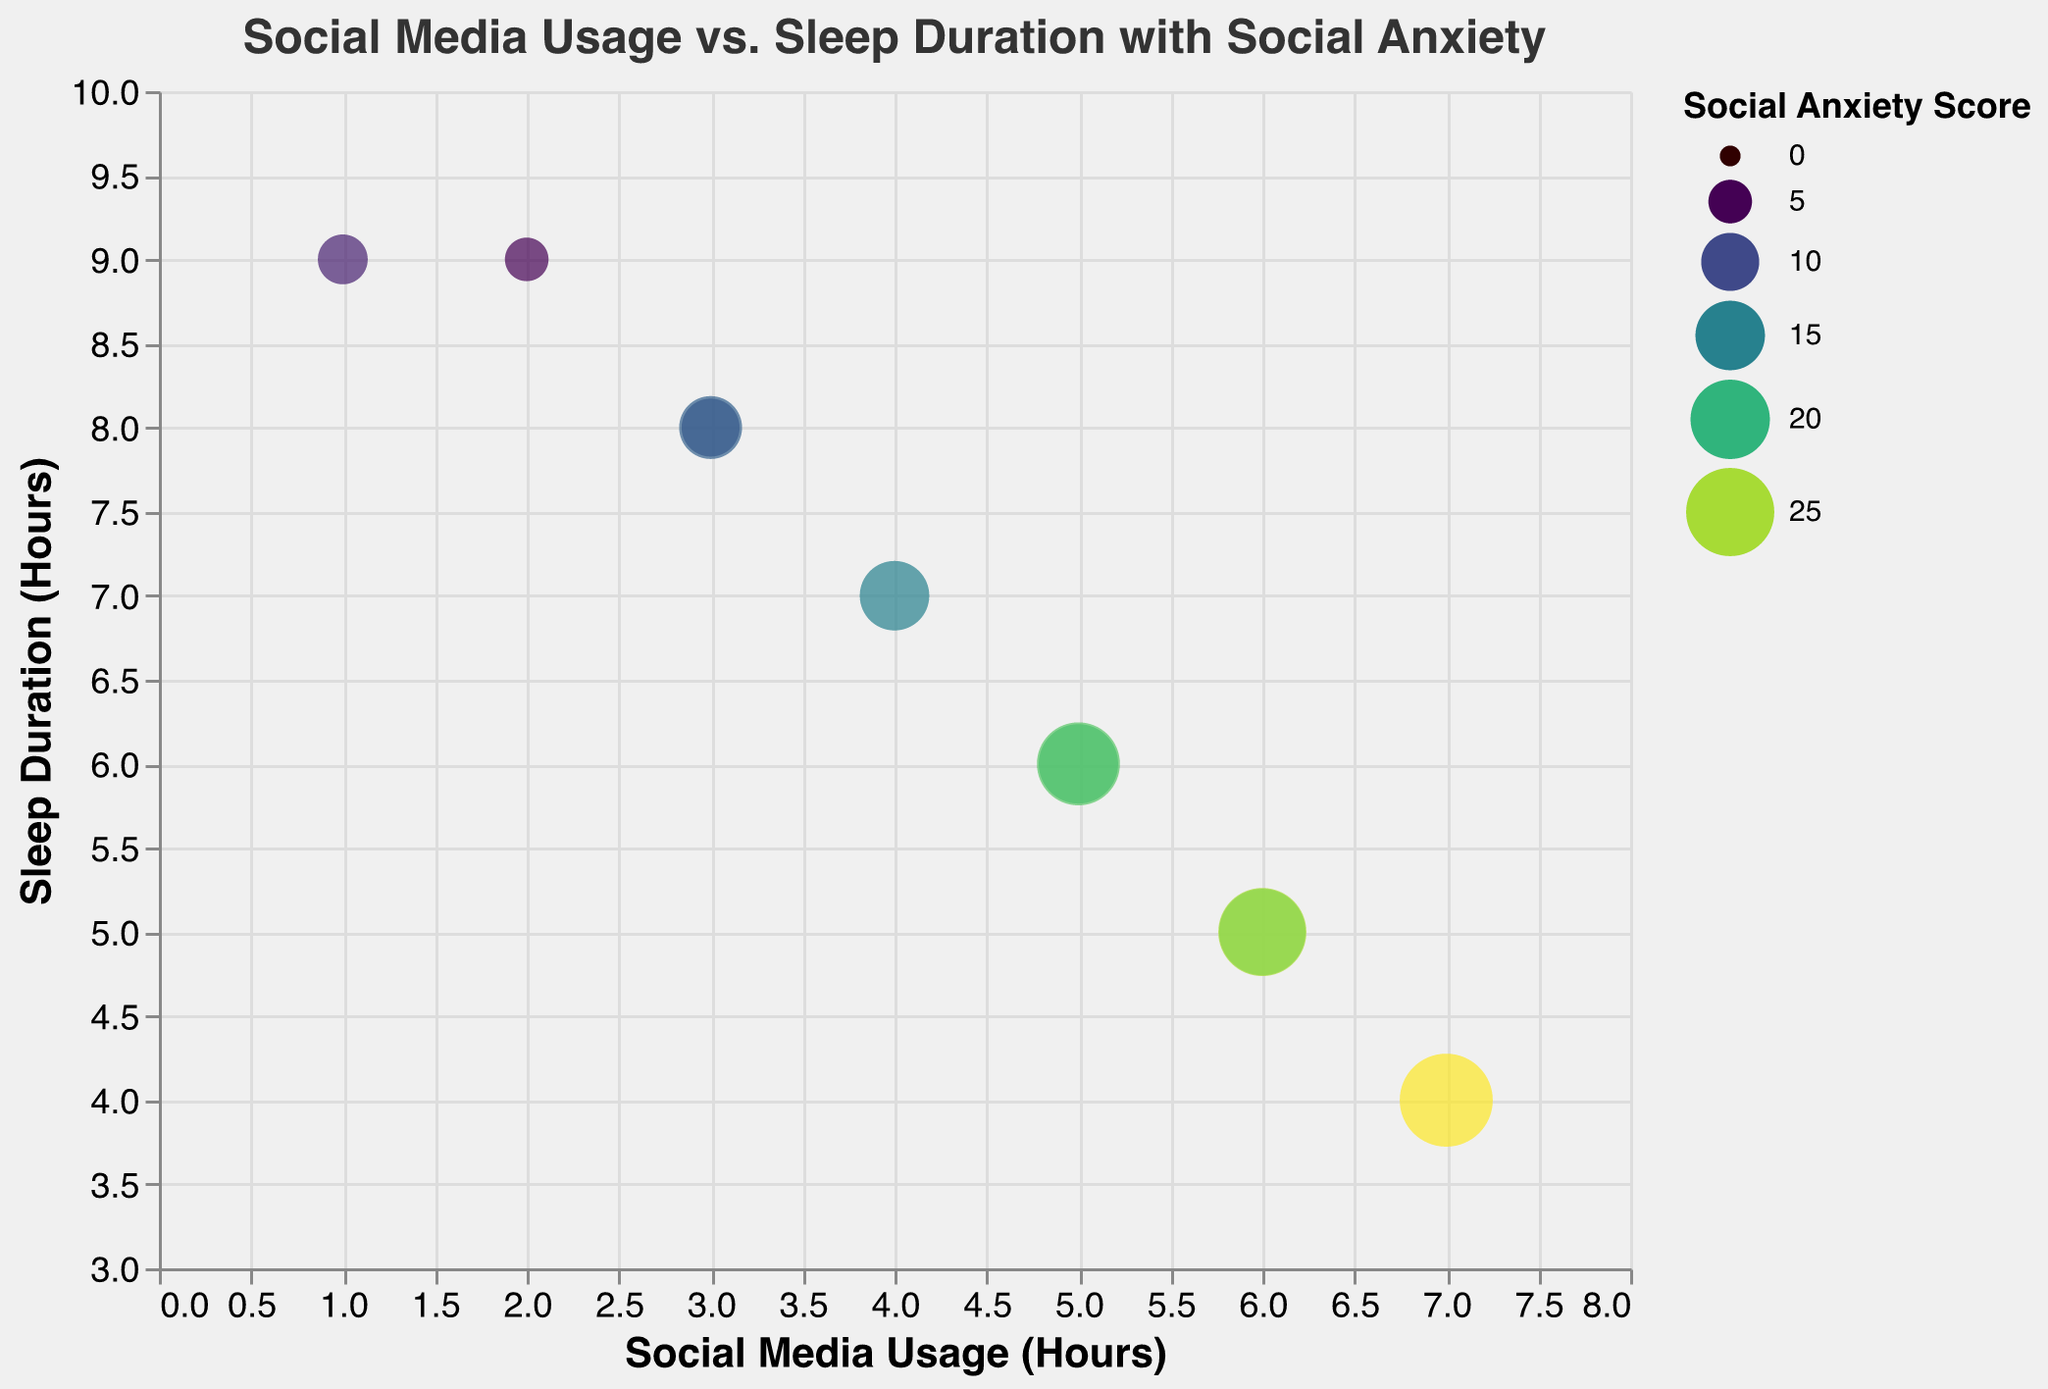How many students have a sleep duration of 8 hours? By referring to the y-axis labeled "Sleep Duration (Hours)" and identifying the data points with y = 8, we find there are two students.
Answer: 2 Which student has the highest social media usage? By looking at the x-axis labeled "Social Media Usage (Hours)" and identifying the data point farthest from the origin (right), we find that Daniel uses social media the most with 7 hours.
Answer: Daniel What is the average sleep duration of students who use social media for 5 hours? There are two students, Emily and Matthew, with social media usage of 5 hours (x = 5). Their respective sleep durations (y) are 6 hours each, so the average is (6 + 6)/2 = 6 hours.
Answer: 6 hours Which student has the highest social anxiety score? The size and color legends indicate social anxiety. The largest, darkest bubble corresponds to Daniel with a social anxiety score of 28.
Answer: Daniel What is the correlation between social media usage and sleep duration? Observing the scatter pattern of the data points, we see that as social media usage increases, sleep duration tends to decrease, indicating a negative correlation.
Answer: Negative correlation Which students have the same social media usage and sleep duration, and what is their social anxiety score? Referring to points with identical x and y values, Emma and Jason both use social media for 3 hours and sleep for 8 hours. Their social anxiety scores are 12 and 10, respectively.
Answer: Emma (12), Jason (10) Who sleeps the least and how much is the sleep duration? By identifying the data point with the lowest y-axis value and examining student information, we find that Daniel and Sarah sleep the least, with a duration of 4 and 5 hours, respectively.
Answer: Daniel (4 hours), Sarah (5 hours) What's the total social media usage for students who sleep 9 hours? Referring to the y-axis for sleep duration of 9 hours, Michael and David’s corresponding social media usage (2 and 1 hours, respectively) sums up to 3 hours.
Answer: 3 hours What is the social anxiety score for students with the maximum sleep duration? The maximum sleep duration from the y-axis (Sleep Duration) is 9 hours. Michael and David who sleep 9 hours have anxiety scores of 5 and 7, respectively.
Answer: Michael (5), David (7) What is the relationship between the size and color of the bubbles and social anxiety score? The legend indicates that both size and color are proportional to the social anxiety score: larger and darker bubbles represent higher scores.
Answer: Proportional relationship 